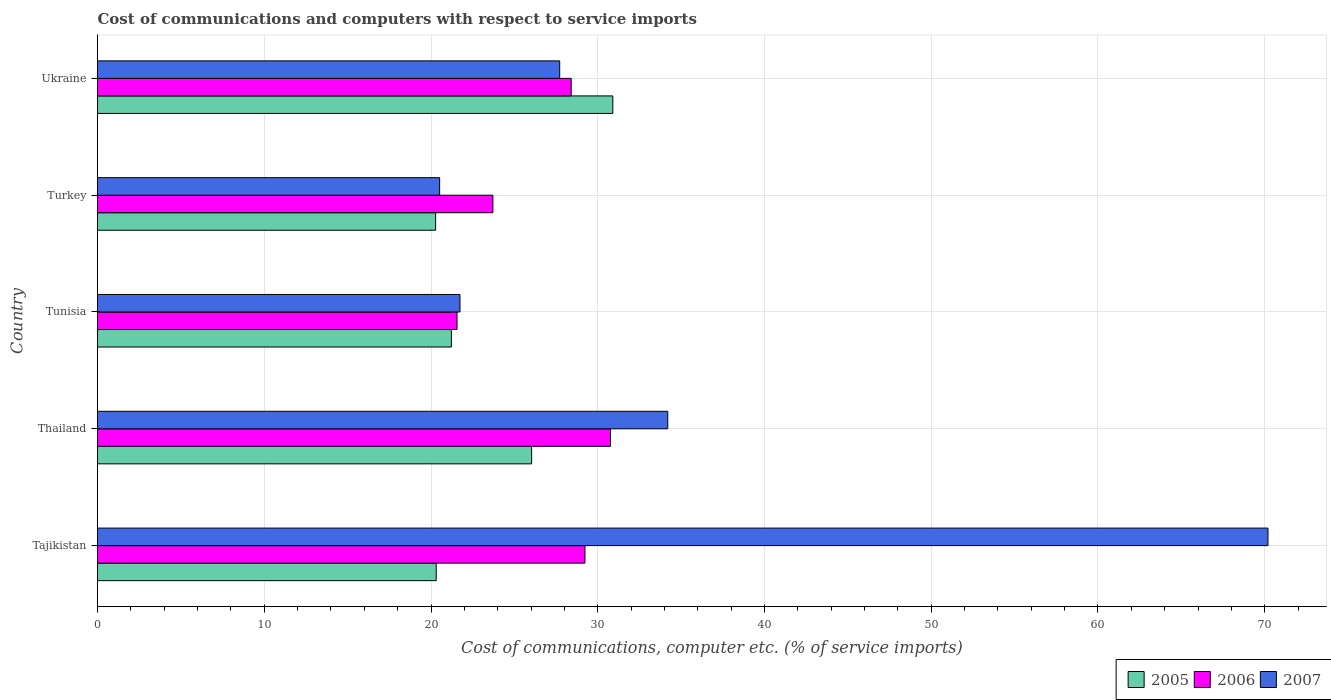How many groups of bars are there?
Offer a very short reply. 5. How many bars are there on the 3rd tick from the bottom?
Ensure brevity in your answer.  3. What is the label of the 1st group of bars from the top?
Offer a terse response. Ukraine. What is the cost of communications and computers in 2006 in Tunisia?
Your response must be concise. 21.56. Across all countries, what is the maximum cost of communications and computers in 2006?
Your response must be concise. 30.77. Across all countries, what is the minimum cost of communications and computers in 2006?
Make the answer very short. 21.56. In which country was the cost of communications and computers in 2006 maximum?
Provide a succinct answer. Thailand. In which country was the cost of communications and computers in 2005 minimum?
Ensure brevity in your answer.  Turkey. What is the total cost of communications and computers in 2006 in the graph?
Your answer should be very brief. 133.68. What is the difference between the cost of communications and computers in 2007 in Tajikistan and that in Turkey?
Offer a terse response. 49.68. What is the difference between the cost of communications and computers in 2005 in Thailand and the cost of communications and computers in 2006 in Turkey?
Your answer should be very brief. 2.32. What is the average cost of communications and computers in 2006 per country?
Offer a very short reply. 26.74. What is the difference between the cost of communications and computers in 2005 and cost of communications and computers in 2006 in Ukraine?
Keep it short and to the point. 2.5. In how many countries, is the cost of communications and computers in 2007 greater than 2 %?
Provide a succinct answer. 5. What is the ratio of the cost of communications and computers in 2007 in Tajikistan to that in Tunisia?
Provide a short and direct response. 3.23. Is the cost of communications and computers in 2005 in Tunisia less than that in Ukraine?
Your answer should be compact. Yes. Is the difference between the cost of communications and computers in 2005 in Thailand and Turkey greater than the difference between the cost of communications and computers in 2006 in Thailand and Turkey?
Give a very brief answer. No. What is the difference between the highest and the second highest cost of communications and computers in 2007?
Offer a terse response. 36. What is the difference between the highest and the lowest cost of communications and computers in 2007?
Provide a succinct answer. 49.68. In how many countries, is the cost of communications and computers in 2005 greater than the average cost of communications and computers in 2005 taken over all countries?
Offer a terse response. 2. Is it the case that in every country, the sum of the cost of communications and computers in 2005 and cost of communications and computers in 2007 is greater than the cost of communications and computers in 2006?
Your response must be concise. Yes. How many bars are there?
Provide a succinct answer. 15. How many countries are there in the graph?
Offer a very short reply. 5. What is the difference between two consecutive major ticks on the X-axis?
Your answer should be compact. 10. Does the graph contain any zero values?
Ensure brevity in your answer.  No. Where does the legend appear in the graph?
Offer a terse response. Bottom right. How are the legend labels stacked?
Ensure brevity in your answer.  Horizontal. What is the title of the graph?
Keep it short and to the point. Cost of communications and computers with respect to service imports. Does "1998" appear as one of the legend labels in the graph?
Provide a succinct answer. No. What is the label or title of the X-axis?
Provide a short and direct response. Cost of communications, computer etc. (% of service imports). What is the label or title of the Y-axis?
Provide a short and direct response. Country. What is the Cost of communications, computer etc. (% of service imports) in 2005 in Tajikistan?
Your answer should be very brief. 20.31. What is the Cost of communications, computer etc. (% of service imports) in 2006 in Tajikistan?
Keep it short and to the point. 29.23. What is the Cost of communications, computer etc. (% of service imports) in 2007 in Tajikistan?
Offer a terse response. 70.2. What is the Cost of communications, computer etc. (% of service imports) in 2005 in Thailand?
Keep it short and to the point. 26.04. What is the Cost of communications, computer etc. (% of service imports) in 2006 in Thailand?
Offer a very short reply. 30.77. What is the Cost of communications, computer etc. (% of service imports) of 2007 in Thailand?
Provide a succinct answer. 34.2. What is the Cost of communications, computer etc. (% of service imports) of 2005 in Tunisia?
Your answer should be very brief. 21.22. What is the Cost of communications, computer etc. (% of service imports) in 2006 in Tunisia?
Give a very brief answer. 21.56. What is the Cost of communications, computer etc. (% of service imports) in 2007 in Tunisia?
Make the answer very short. 21.74. What is the Cost of communications, computer etc. (% of service imports) in 2005 in Turkey?
Your response must be concise. 20.28. What is the Cost of communications, computer etc. (% of service imports) in 2006 in Turkey?
Offer a terse response. 23.71. What is the Cost of communications, computer etc. (% of service imports) in 2007 in Turkey?
Offer a very short reply. 20.52. What is the Cost of communications, computer etc. (% of service imports) of 2005 in Ukraine?
Give a very brief answer. 30.9. What is the Cost of communications, computer etc. (% of service imports) of 2006 in Ukraine?
Your answer should be compact. 28.41. What is the Cost of communications, computer etc. (% of service imports) of 2007 in Ukraine?
Your answer should be very brief. 27.72. Across all countries, what is the maximum Cost of communications, computer etc. (% of service imports) in 2005?
Provide a short and direct response. 30.9. Across all countries, what is the maximum Cost of communications, computer etc. (% of service imports) in 2006?
Offer a very short reply. 30.77. Across all countries, what is the maximum Cost of communications, computer etc. (% of service imports) of 2007?
Your answer should be very brief. 70.2. Across all countries, what is the minimum Cost of communications, computer etc. (% of service imports) of 2005?
Provide a short and direct response. 20.28. Across all countries, what is the minimum Cost of communications, computer etc. (% of service imports) of 2006?
Your response must be concise. 21.56. Across all countries, what is the minimum Cost of communications, computer etc. (% of service imports) of 2007?
Keep it short and to the point. 20.52. What is the total Cost of communications, computer etc. (% of service imports) in 2005 in the graph?
Offer a very short reply. 118.75. What is the total Cost of communications, computer etc. (% of service imports) of 2006 in the graph?
Offer a terse response. 133.68. What is the total Cost of communications, computer etc. (% of service imports) of 2007 in the graph?
Provide a short and direct response. 174.37. What is the difference between the Cost of communications, computer etc. (% of service imports) in 2005 in Tajikistan and that in Thailand?
Ensure brevity in your answer.  -5.72. What is the difference between the Cost of communications, computer etc. (% of service imports) in 2006 in Tajikistan and that in Thailand?
Offer a very short reply. -1.53. What is the difference between the Cost of communications, computer etc. (% of service imports) in 2007 in Tajikistan and that in Thailand?
Offer a very short reply. 36. What is the difference between the Cost of communications, computer etc. (% of service imports) in 2005 in Tajikistan and that in Tunisia?
Provide a short and direct response. -0.91. What is the difference between the Cost of communications, computer etc. (% of service imports) of 2006 in Tajikistan and that in Tunisia?
Provide a succinct answer. 7.67. What is the difference between the Cost of communications, computer etc. (% of service imports) in 2007 in Tajikistan and that in Tunisia?
Ensure brevity in your answer.  48.46. What is the difference between the Cost of communications, computer etc. (% of service imports) in 2005 in Tajikistan and that in Turkey?
Provide a succinct answer. 0.04. What is the difference between the Cost of communications, computer etc. (% of service imports) of 2006 in Tajikistan and that in Turkey?
Your response must be concise. 5.52. What is the difference between the Cost of communications, computer etc. (% of service imports) of 2007 in Tajikistan and that in Turkey?
Give a very brief answer. 49.68. What is the difference between the Cost of communications, computer etc. (% of service imports) of 2005 in Tajikistan and that in Ukraine?
Ensure brevity in your answer.  -10.59. What is the difference between the Cost of communications, computer etc. (% of service imports) of 2006 in Tajikistan and that in Ukraine?
Provide a short and direct response. 0.83. What is the difference between the Cost of communications, computer etc. (% of service imports) of 2007 in Tajikistan and that in Ukraine?
Offer a terse response. 42.48. What is the difference between the Cost of communications, computer etc. (% of service imports) in 2005 in Thailand and that in Tunisia?
Offer a terse response. 4.81. What is the difference between the Cost of communications, computer etc. (% of service imports) in 2006 in Thailand and that in Tunisia?
Offer a terse response. 9.2. What is the difference between the Cost of communications, computer etc. (% of service imports) of 2007 in Thailand and that in Tunisia?
Your answer should be very brief. 12.46. What is the difference between the Cost of communications, computer etc. (% of service imports) in 2005 in Thailand and that in Turkey?
Offer a terse response. 5.76. What is the difference between the Cost of communications, computer etc. (% of service imports) in 2006 in Thailand and that in Turkey?
Give a very brief answer. 7.05. What is the difference between the Cost of communications, computer etc. (% of service imports) in 2007 in Thailand and that in Turkey?
Keep it short and to the point. 13.68. What is the difference between the Cost of communications, computer etc. (% of service imports) of 2005 in Thailand and that in Ukraine?
Provide a succinct answer. -4.87. What is the difference between the Cost of communications, computer etc. (% of service imports) in 2006 in Thailand and that in Ukraine?
Your response must be concise. 2.36. What is the difference between the Cost of communications, computer etc. (% of service imports) in 2007 in Thailand and that in Ukraine?
Give a very brief answer. 6.48. What is the difference between the Cost of communications, computer etc. (% of service imports) of 2005 in Tunisia and that in Turkey?
Offer a very short reply. 0.95. What is the difference between the Cost of communications, computer etc. (% of service imports) in 2006 in Tunisia and that in Turkey?
Keep it short and to the point. -2.15. What is the difference between the Cost of communications, computer etc. (% of service imports) of 2007 in Tunisia and that in Turkey?
Offer a very short reply. 1.22. What is the difference between the Cost of communications, computer etc. (% of service imports) of 2005 in Tunisia and that in Ukraine?
Keep it short and to the point. -9.68. What is the difference between the Cost of communications, computer etc. (% of service imports) of 2006 in Tunisia and that in Ukraine?
Provide a short and direct response. -6.85. What is the difference between the Cost of communications, computer etc. (% of service imports) in 2007 in Tunisia and that in Ukraine?
Offer a terse response. -5.98. What is the difference between the Cost of communications, computer etc. (% of service imports) of 2005 in Turkey and that in Ukraine?
Provide a succinct answer. -10.63. What is the difference between the Cost of communications, computer etc. (% of service imports) of 2006 in Turkey and that in Ukraine?
Your answer should be very brief. -4.7. What is the difference between the Cost of communications, computer etc. (% of service imports) in 2007 in Turkey and that in Ukraine?
Offer a terse response. -7.2. What is the difference between the Cost of communications, computer etc. (% of service imports) in 2005 in Tajikistan and the Cost of communications, computer etc. (% of service imports) in 2006 in Thailand?
Your answer should be compact. -10.45. What is the difference between the Cost of communications, computer etc. (% of service imports) in 2005 in Tajikistan and the Cost of communications, computer etc. (% of service imports) in 2007 in Thailand?
Make the answer very short. -13.89. What is the difference between the Cost of communications, computer etc. (% of service imports) of 2006 in Tajikistan and the Cost of communications, computer etc. (% of service imports) of 2007 in Thailand?
Your answer should be compact. -4.96. What is the difference between the Cost of communications, computer etc. (% of service imports) in 2005 in Tajikistan and the Cost of communications, computer etc. (% of service imports) in 2006 in Tunisia?
Ensure brevity in your answer.  -1.25. What is the difference between the Cost of communications, computer etc. (% of service imports) of 2005 in Tajikistan and the Cost of communications, computer etc. (% of service imports) of 2007 in Tunisia?
Offer a terse response. -1.42. What is the difference between the Cost of communications, computer etc. (% of service imports) in 2006 in Tajikistan and the Cost of communications, computer etc. (% of service imports) in 2007 in Tunisia?
Your response must be concise. 7.5. What is the difference between the Cost of communications, computer etc. (% of service imports) of 2005 in Tajikistan and the Cost of communications, computer etc. (% of service imports) of 2006 in Turkey?
Provide a short and direct response. -3.4. What is the difference between the Cost of communications, computer etc. (% of service imports) of 2005 in Tajikistan and the Cost of communications, computer etc. (% of service imports) of 2007 in Turkey?
Make the answer very short. -0.2. What is the difference between the Cost of communications, computer etc. (% of service imports) of 2006 in Tajikistan and the Cost of communications, computer etc. (% of service imports) of 2007 in Turkey?
Make the answer very short. 8.72. What is the difference between the Cost of communications, computer etc. (% of service imports) of 2005 in Tajikistan and the Cost of communications, computer etc. (% of service imports) of 2006 in Ukraine?
Your answer should be compact. -8.1. What is the difference between the Cost of communications, computer etc. (% of service imports) in 2005 in Tajikistan and the Cost of communications, computer etc. (% of service imports) in 2007 in Ukraine?
Ensure brevity in your answer.  -7.41. What is the difference between the Cost of communications, computer etc. (% of service imports) in 2006 in Tajikistan and the Cost of communications, computer etc. (% of service imports) in 2007 in Ukraine?
Keep it short and to the point. 1.52. What is the difference between the Cost of communications, computer etc. (% of service imports) in 2005 in Thailand and the Cost of communications, computer etc. (% of service imports) in 2006 in Tunisia?
Ensure brevity in your answer.  4.47. What is the difference between the Cost of communications, computer etc. (% of service imports) of 2005 in Thailand and the Cost of communications, computer etc. (% of service imports) of 2007 in Tunisia?
Keep it short and to the point. 4.3. What is the difference between the Cost of communications, computer etc. (% of service imports) of 2006 in Thailand and the Cost of communications, computer etc. (% of service imports) of 2007 in Tunisia?
Your answer should be compact. 9.03. What is the difference between the Cost of communications, computer etc. (% of service imports) in 2005 in Thailand and the Cost of communications, computer etc. (% of service imports) in 2006 in Turkey?
Keep it short and to the point. 2.32. What is the difference between the Cost of communications, computer etc. (% of service imports) in 2005 in Thailand and the Cost of communications, computer etc. (% of service imports) in 2007 in Turkey?
Ensure brevity in your answer.  5.52. What is the difference between the Cost of communications, computer etc. (% of service imports) of 2006 in Thailand and the Cost of communications, computer etc. (% of service imports) of 2007 in Turkey?
Your answer should be very brief. 10.25. What is the difference between the Cost of communications, computer etc. (% of service imports) in 2005 in Thailand and the Cost of communications, computer etc. (% of service imports) in 2006 in Ukraine?
Your answer should be very brief. -2.37. What is the difference between the Cost of communications, computer etc. (% of service imports) of 2005 in Thailand and the Cost of communications, computer etc. (% of service imports) of 2007 in Ukraine?
Make the answer very short. -1.68. What is the difference between the Cost of communications, computer etc. (% of service imports) of 2006 in Thailand and the Cost of communications, computer etc. (% of service imports) of 2007 in Ukraine?
Provide a succinct answer. 3.05. What is the difference between the Cost of communications, computer etc. (% of service imports) in 2005 in Tunisia and the Cost of communications, computer etc. (% of service imports) in 2006 in Turkey?
Ensure brevity in your answer.  -2.49. What is the difference between the Cost of communications, computer etc. (% of service imports) of 2005 in Tunisia and the Cost of communications, computer etc. (% of service imports) of 2007 in Turkey?
Keep it short and to the point. 0.7. What is the difference between the Cost of communications, computer etc. (% of service imports) of 2006 in Tunisia and the Cost of communications, computer etc. (% of service imports) of 2007 in Turkey?
Keep it short and to the point. 1.04. What is the difference between the Cost of communications, computer etc. (% of service imports) in 2005 in Tunisia and the Cost of communications, computer etc. (% of service imports) in 2006 in Ukraine?
Provide a short and direct response. -7.19. What is the difference between the Cost of communications, computer etc. (% of service imports) in 2005 in Tunisia and the Cost of communications, computer etc. (% of service imports) in 2007 in Ukraine?
Offer a terse response. -6.5. What is the difference between the Cost of communications, computer etc. (% of service imports) of 2006 in Tunisia and the Cost of communications, computer etc. (% of service imports) of 2007 in Ukraine?
Give a very brief answer. -6.16. What is the difference between the Cost of communications, computer etc. (% of service imports) in 2005 in Turkey and the Cost of communications, computer etc. (% of service imports) in 2006 in Ukraine?
Ensure brevity in your answer.  -8.13. What is the difference between the Cost of communications, computer etc. (% of service imports) in 2005 in Turkey and the Cost of communications, computer etc. (% of service imports) in 2007 in Ukraine?
Offer a very short reply. -7.44. What is the difference between the Cost of communications, computer etc. (% of service imports) of 2006 in Turkey and the Cost of communications, computer etc. (% of service imports) of 2007 in Ukraine?
Keep it short and to the point. -4.01. What is the average Cost of communications, computer etc. (% of service imports) of 2005 per country?
Provide a succinct answer. 23.75. What is the average Cost of communications, computer etc. (% of service imports) of 2006 per country?
Keep it short and to the point. 26.74. What is the average Cost of communications, computer etc. (% of service imports) of 2007 per country?
Provide a short and direct response. 34.87. What is the difference between the Cost of communications, computer etc. (% of service imports) of 2005 and Cost of communications, computer etc. (% of service imports) of 2006 in Tajikistan?
Make the answer very short. -8.92. What is the difference between the Cost of communications, computer etc. (% of service imports) of 2005 and Cost of communications, computer etc. (% of service imports) of 2007 in Tajikistan?
Your answer should be compact. -49.88. What is the difference between the Cost of communications, computer etc. (% of service imports) in 2006 and Cost of communications, computer etc. (% of service imports) in 2007 in Tajikistan?
Your answer should be compact. -40.96. What is the difference between the Cost of communications, computer etc. (% of service imports) of 2005 and Cost of communications, computer etc. (% of service imports) of 2006 in Thailand?
Your response must be concise. -4.73. What is the difference between the Cost of communications, computer etc. (% of service imports) in 2005 and Cost of communications, computer etc. (% of service imports) in 2007 in Thailand?
Your answer should be very brief. -8.16. What is the difference between the Cost of communications, computer etc. (% of service imports) in 2006 and Cost of communications, computer etc. (% of service imports) in 2007 in Thailand?
Your answer should be very brief. -3.43. What is the difference between the Cost of communications, computer etc. (% of service imports) in 2005 and Cost of communications, computer etc. (% of service imports) in 2006 in Tunisia?
Your answer should be very brief. -0.34. What is the difference between the Cost of communications, computer etc. (% of service imports) in 2005 and Cost of communications, computer etc. (% of service imports) in 2007 in Tunisia?
Your answer should be compact. -0.52. What is the difference between the Cost of communications, computer etc. (% of service imports) of 2006 and Cost of communications, computer etc. (% of service imports) of 2007 in Tunisia?
Provide a short and direct response. -0.18. What is the difference between the Cost of communications, computer etc. (% of service imports) of 2005 and Cost of communications, computer etc. (% of service imports) of 2006 in Turkey?
Offer a terse response. -3.44. What is the difference between the Cost of communications, computer etc. (% of service imports) in 2005 and Cost of communications, computer etc. (% of service imports) in 2007 in Turkey?
Offer a terse response. -0.24. What is the difference between the Cost of communications, computer etc. (% of service imports) of 2006 and Cost of communications, computer etc. (% of service imports) of 2007 in Turkey?
Provide a short and direct response. 3.19. What is the difference between the Cost of communications, computer etc. (% of service imports) of 2005 and Cost of communications, computer etc. (% of service imports) of 2006 in Ukraine?
Ensure brevity in your answer.  2.5. What is the difference between the Cost of communications, computer etc. (% of service imports) in 2005 and Cost of communications, computer etc. (% of service imports) in 2007 in Ukraine?
Give a very brief answer. 3.19. What is the difference between the Cost of communications, computer etc. (% of service imports) of 2006 and Cost of communications, computer etc. (% of service imports) of 2007 in Ukraine?
Keep it short and to the point. 0.69. What is the ratio of the Cost of communications, computer etc. (% of service imports) in 2005 in Tajikistan to that in Thailand?
Ensure brevity in your answer.  0.78. What is the ratio of the Cost of communications, computer etc. (% of service imports) of 2006 in Tajikistan to that in Thailand?
Offer a terse response. 0.95. What is the ratio of the Cost of communications, computer etc. (% of service imports) of 2007 in Tajikistan to that in Thailand?
Provide a short and direct response. 2.05. What is the ratio of the Cost of communications, computer etc. (% of service imports) of 2005 in Tajikistan to that in Tunisia?
Keep it short and to the point. 0.96. What is the ratio of the Cost of communications, computer etc. (% of service imports) of 2006 in Tajikistan to that in Tunisia?
Keep it short and to the point. 1.36. What is the ratio of the Cost of communications, computer etc. (% of service imports) in 2007 in Tajikistan to that in Tunisia?
Make the answer very short. 3.23. What is the ratio of the Cost of communications, computer etc. (% of service imports) of 2005 in Tajikistan to that in Turkey?
Give a very brief answer. 1. What is the ratio of the Cost of communications, computer etc. (% of service imports) of 2006 in Tajikistan to that in Turkey?
Your answer should be compact. 1.23. What is the ratio of the Cost of communications, computer etc. (% of service imports) of 2007 in Tajikistan to that in Turkey?
Provide a short and direct response. 3.42. What is the ratio of the Cost of communications, computer etc. (% of service imports) of 2005 in Tajikistan to that in Ukraine?
Offer a very short reply. 0.66. What is the ratio of the Cost of communications, computer etc. (% of service imports) of 2006 in Tajikistan to that in Ukraine?
Your answer should be compact. 1.03. What is the ratio of the Cost of communications, computer etc. (% of service imports) in 2007 in Tajikistan to that in Ukraine?
Keep it short and to the point. 2.53. What is the ratio of the Cost of communications, computer etc. (% of service imports) of 2005 in Thailand to that in Tunisia?
Give a very brief answer. 1.23. What is the ratio of the Cost of communications, computer etc. (% of service imports) in 2006 in Thailand to that in Tunisia?
Provide a short and direct response. 1.43. What is the ratio of the Cost of communications, computer etc. (% of service imports) of 2007 in Thailand to that in Tunisia?
Offer a very short reply. 1.57. What is the ratio of the Cost of communications, computer etc. (% of service imports) of 2005 in Thailand to that in Turkey?
Your response must be concise. 1.28. What is the ratio of the Cost of communications, computer etc. (% of service imports) in 2006 in Thailand to that in Turkey?
Make the answer very short. 1.3. What is the ratio of the Cost of communications, computer etc. (% of service imports) in 2007 in Thailand to that in Turkey?
Your response must be concise. 1.67. What is the ratio of the Cost of communications, computer etc. (% of service imports) of 2005 in Thailand to that in Ukraine?
Your answer should be very brief. 0.84. What is the ratio of the Cost of communications, computer etc. (% of service imports) of 2006 in Thailand to that in Ukraine?
Your response must be concise. 1.08. What is the ratio of the Cost of communications, computer etc. (% of service imports) in 2007 in Thailand to that in Ukraine?
Make the answer very short. 1.23. What is the ratio of the Cost of communications, computer etc. (% of service imports) of 2005 in Tunisia to that in Turkey?
Your answer should be very brief. 1.05. What is the ratio of the Cost of communications, computer etc. (% of service imports) of 2006 in Tunisia to that in Turkey?
Your response must be concise. 0.91. What is the ratio of the Cost of communications, computer etc. (% of service imports) in 2007 in Tunisia to that in Turkey?
Offer a very short reply. 1.06. What is the ratio of the Cost of communications, computer etc. (% of service imports) in 2005 in Tunisia to that in Ukraine?
Offer a terse response. 0.69. What is the ratio of the Cost of communications, computer etc. (% of service imports) of 2006 in Tunisia to that in Ukraine?
Make the answer very short. 0.76. What is the ratio of the Cost of communications, computer etc. (% of service imports) of 2007 in Tunisia to that in Ukraine?
Provide a short and direct response. 0.78. What is the ratio of the Cost of communications, computer etc. (% of service imports) in 2005 in Turkey to that in Ukraine?
Your answer should be compact. 0.66. What is the ratio of the Cost of communications, computer etc. (% of service imports) in 2006 in Turkey to that in Ukraine?
Give a very brief answer. 0.83. What is the ratio of the Cost of communications, computer etc. (% of service imports) in 2007 in Turkey to that in Ukraine?
Your response must be concise. 0.74. What is the difference between the highest and the second highest Cost of communications, computer etc. (% of service imports) in 2005?
Make the answer very short. 4.87. What is the difference between the highest and the second highest Cost of communications, computer etc. (% of service imports) in 2006?
Keep it short and to the point. 1.53. What is the difference between the highest and the second highest Cost of communications, computer etc. (% of service imports) of 2007?
Give a very brief answer. 36. What is the difference between the highest and the lowest Cost of communications, computer etc. (% of service imports) of 2005?
Your answer should be very brief. 10.63. What is the difference between the highest and the lowest Cost of communications, computer etc. (% of service imports) of 2006?
Your response must be concise. 9.2. What is the difference between the highest and the lowest Cost of communications, computer etc. (% of service imports) in 2007?
Offer a very short reply. 49.68. 